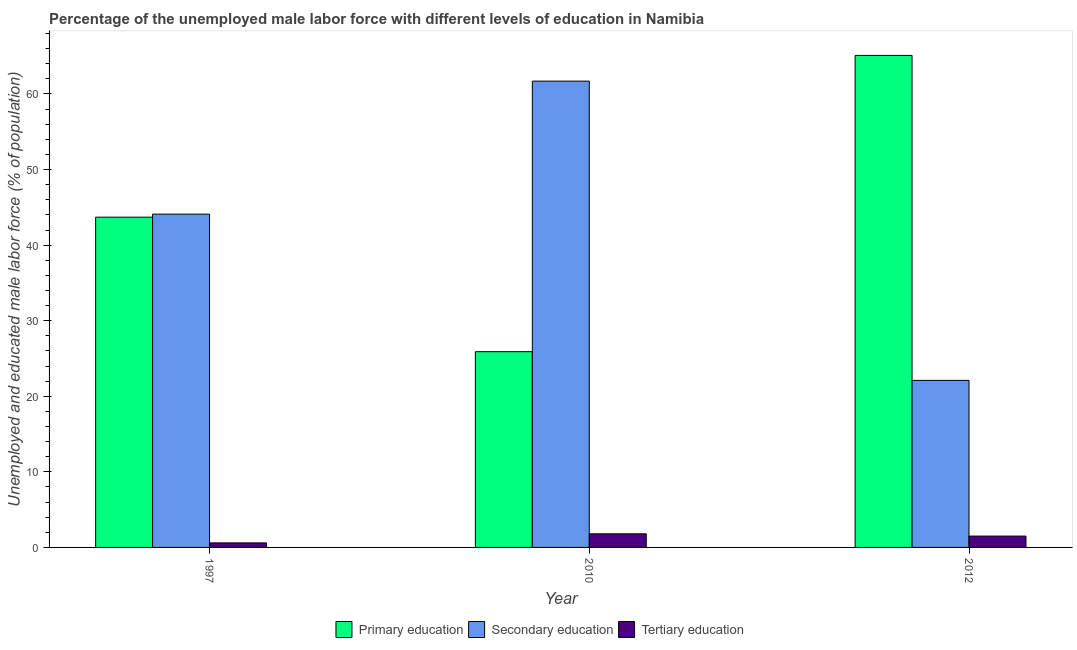How many groups of bars are there?
Provide a short and direct response. 3. How many bars are there on the 2nd tick from the left?
Make the answer very short. 3. What is the label of the 2nd group of bars from the left?
Make the answer very short. 2010. What is the percentage of male labor force who received secondary education in 2010?
Provide a succinct answer. 61.7. Across all years, what is the maximum percentage of male labor force who received primary education?
Your answer should be very brief. 65.1. Across all years, what is the minimum percentage of male labor force who received primary education?
Offer a very short reply. 25.9. In which year was the percentage of male labor force who received secondary education minimum?
Keep it short and to the point. 2012. What is the total percentage of male labor force who received secondary education in the graph?
Provide a succinct answer. 127.9. What is the difference between the percentage of male labor force who received primary education in 2010 and that in 2012?
Provide a succinct answer. -39.2. What is the difference between the percentage of male labor force who received primary education in 2010 and the percentage of male labor force who received secondary education in 2012?
Keep it short and to the point. -39.2. What is the average percentage of male labor force who received secondary education per year?
Give a very brief answer. 42.63. What is the ratio of the percentage of male labor force who received tertiary education in 1997 to that in 2012?
Offer a very short reply. 0.4. Is the percentage of male labor force who received primary education in 1997 less than that in 2010?
Keep it short and to the point. No. Is the difference between the percentage of male labor force who received primary education in 1997 and 2012 greater than the difference between the percentage of male labor force who received tertiary education in 1997 and 2012?
Your answer should be very brief. No. What is the difference between the highest and the second highest percentage of male labor force who received secondary education?
Offer a very short reply. 17.6. What is the difference between the highest and the lowest percentage of male labor force who received secondary education?
Make the answer very short. 39.6. In how many years, is the percentage of male labor force who received primary education greater than the average percentage of male labor force who received primary education taken over all years?
Make the answer very short. 1. What does the 1st bar from the right in 2012 represents?
Provide a succinct answer. Tertiary education. Is it the case that in every year, the sum of the percentage of male labor force who received primary education and percentage of male labor force who received secondary education is greater than the percentage of male labor force who received tertiary education?
Ensure brevity in your answer.  Yes. How many bars are there?
Provide a short and direct response. 9. What is the difference between two consecutive major ticks on the Y-axis?
Your response must be concise. 10. Does the graph contain any zero values?
Give a very brief answer. No. Where does the legend appear in the graph?
Your response must be concise. Bottom center. How many legend labels are there?
Keep it short and to the point. 3. What is the title of the graph?
Your answer should be compact. Percentage of the unemployed male labor force with different levels of education in Namibia. What is the label or title of the X-axis?
Offer a very short reply. Year. What is the label or title of the Y-axis?
Keep it short and to the point. Unemployed and educated male labor force (% of population). What is the Unemployed and educated male labor force (% of population) in Primary education in 1997?
Offer a terse response. 43.7. What is the Unemployed and educated male labor force (% of population) in Secondary education in 1997?
Provide a short and direct response. 44.1. What is the Unemployed and educated male labor force (% of population) of Tertiary education in 1997?
Your answer should be very brief. 0.6. What is the Unemployed and educated male labor force (% of population) in Primary education in 2010?
Your answer should be very brief. 25.9. What is the Unemployed and educated male labor force (% of population) in Secondary education in 2010?
Keep it short and to the point. 61.7. What is the Unemployed and educated male labor force (% of population) of Tertiary education in 2010?
Your answer should be compact. 1.8. What is the Unemployed and educated male labor force (% of population) of Primary education in 2012?
Your answer should be compact. 65.1. What is the Unemployed and educated male labor force (% of population) in Secondary education in 2012?
Make the answer very short. 22.1. What is the Unemployed and educated male labor force (% of population) in Tertiary education in 2012?
Provide a succinct answer. 1.5. Across all years, what is the maximum Unemployed and educated male labor force (% of population) of Primary education?
Provide a short and direct response. 65.1. Across all years, what is the maximum Unemployed and educated male labor force (% of population) of Secondary education?
Make the answer very short. 61.7. Across all years, what is the maximum Unemployed and educated male labor force (% of population) of Tertiary education?
Offer a very short reply. 1.8. Across all years, what is the minimum Unemployed and educated male labor force (% of population) in Primary education?
Ensure brevity in your answer.  25.9. Across all years, what is the minimum Unemployed and educated male labor force (% of population) of Secondary education?
Offer a terse response. 22.1. Across all years, what is the minimum Unemployed and educated male labor force (% of population) of Tertiary education?
Your answer should be very brief. 0.6. What is the total Unemployed and educated male labor force (% of population) of Primary education in the graph?
Your response must be concise. 134.7. What is the total Unemployed and educated male labor force (% of population) in Secondary education in the graph?
Keep it short and to the point. 127.9. What is the difference between the Unemployed and educated male labor force (% of population) of Secondary education in 1997 and that in 2010?
Make the answer very short. -17.6. What is the difference between the Unemployed and educated male labor force (% of population) of Primary education in 1997 and that in 2012?
Your answer should be compact. -21.4. What is the difference between the Unemployed and educated male labor force (% of population) in Secondary education in 1997 and that in 2012?
Keep it short and to the point. 22. What is the difference between the Unemployed and educated male labor force (% of population) of Tertiary education in 1997 and that in 2012?
Your answer should be compact. -0.9. What is the difference between the Unemployed and educated male labor force (% of population) of Primary education in 2010 and that in 2012?
Keep it short and to the point. -39.2. What is the difference between the Unemployed and educated male labor force (% of population) of Secondary education in 2010 and that in 2012?
Keep it short and to the point. 39.6. What is the difference between the Unemployed and educated male labor force (% of population) in Tertiary education in 2010 and that in 2012?
Your response must be concise. 0.3. What is the difference between the Unemployed and educated male labor force (% of population) of Primary education in 1997 and the Unemployed and educated male labor force (% of population) of Tertiary education in 2010?
Give a very brief answer. 41.9. What is the difference between the Unemployed and educated male labor force (% of population) of Secondary education in 1997 and the Unemployed and educated male labor force (% of population) of Tertiary education in 2010?
Provide a succinct answer. 42.3. What is the difference between the Unemployed and educated male labor force (% of population) of Primary education in 1997 and the Unemployed and educated male labor force (% of population) of Secondary education in 2012?
Provide a succinct answer. 21.6. What is the difference between the Unemployed and educated male labor force (% of population) in Primary education in 1997 and the Unemployed and educated male labor force (% of population) in Tertiary education in 2012?
Your response must be concise. 42.2. What is the difference between the Unemployed and educated male labor force (% of population) in Secondary education in 1997 and the Unemployed and educated male labor force (% of population) in Tertiary education in 2012?
Your response must be concise. 42.6. What is the difference between the Unemployed and educated male labor force (% of population) of Primary education in 2010 and the Unemployed and educated male labor force (% of population) of Tertiary education in 2012?
Offer a very short reply. 24.4. What is the difference between the Unemployed and educated male labor force (% of population) in Secondary education in 2010 and the Unemployed and educated male labor force (% of population) in Tertiary education in 2012?
Your response must be concise. 60.2. What is the average Unemployed and educated male labor force (% of population) in Primary education per year?
Make the answer very short. 44.9. What is the average Unemployed and educated male labor force (% of population) of Secondary education per year?
Make the answer very short. 42.63. What is the average Unemployed and educated male labor force (% of population) of Tertiary education per year?
Provide a short and direct response. 1.3. In the year 1997, what is the difference between the Unemployed and educated male labor force (% of population) in Primary education and Unemployed and educated male labor force (% of population) in Secondary education?
Provide a succinct answer. -0.4. In the year 1997, what is the difference between the Unemployed and educated male labor force (% of population) of Primary education and Unemployed and educated male labor force (% of population) of Tertiary education?
Offer a terse response. 43.1. In the year 1997, what is the difference between the Unemployed and educated male labor force (% of population) of Secondary education and Unemployed and educated male labor force (% of population) of Tertiary education?
Keep it short and to the point. 43.5. In the year 2010, what is the difference between the Unemployed and educated male labor force (% of population) of Primary education and Unemployed and educated male labor force (% of population) of Secondary education?
Provide a succinct answer. -35.8. In the year 2010, what is the difference between the Unemployed and educated male labor force (% of population) in Primary education and Unemployed and educated male labor force (% of population) in Tertiary education?
Offer a terse response. 24.1. In the year 2010, what is the difference between the Unemployed and educated male labor force (% of population) in Secondary education and Unemployed and educated male labor force (% of population) in Tertiary education?
Your answer should be very brief. 59.9. In the year 2012, what is the difference between the Unemployed and educated male labor force (% of population) in Primary education and Unemployed and educated male labor force (% of population) in Secondary education?
Give a very brief answer. 43. In the year 2012, what is the difference between the Unemployed and educated male labor force (% of population) of Primary education and Unemployed and educated male labor force (% of population) of Tertiary education?
Keep it short and to the point. 63.6. In the year 2012, what is the difference between the Unemployed and educated male labor force (% of population) in Secondary education and Unemployed and educated male labor force (% of population) in Tertiary education?
Your response must be concise. 20.6. What is the ratio of the Unemployed and educated male labor force (% of population) in Primary education in 1997 to that in 2010?
Make the answer very short. 1.69. What is the ratio of the Unemployed and educated male labor force (% of population) of Secondary education in 1997 to that in 2010?
Your answer should be compact. 0.71. What is the ratio of the Unemployed and educated male labor force (% of population) of Primary education in 1997 to that in 2012?
Make the answer very short. 0.67. What is the ratio of the Unemployed and educated male labor force (% of population) in Secondary education in 1997 to that in 2012?
Provide a short and direct response. 2. What is the ratio of the Unemployed and educated male labor force (% of population) of Tertiary education in 1997 to that in 2012?
Keep it short and to the point. 0.4. What is the ratio of the Unemployed and educated male labor force (% of population) of Primary education in 2010 to that in 2012?
Provide a short and direct response. 0.4. What is the ratio of the Unemployed and educated male labor force (% of population) of Secondary education in 2010 to that in 2012?
Your answer should be compact. 2.79. What is the ratio of the Unemployed and educated male labor force (% of population) in Tertiary education in 2010 to that in 2012?
Your answer should be very brief. 1.2. What is the difference between the highest and the second highest Unemployed and educated male labor force (% of population) in Primary education?
Give a very brief answer. 21.4. What is the difference between the highest and the lowest Unemployed and educated male labor force (% of population) of Primary education?
Your answer should be very brief. 39.2. What is the difference between the highest and the lowest Unemployed and educated male labor force (% of population) of Secondary education?
Ensure brevity in your answer.  39.6. What is the difference between the highest and the lowest Unemployed and educated male labor force (% of population) of Tertiary education?
Ensure brevity in your answer.  1.2. 